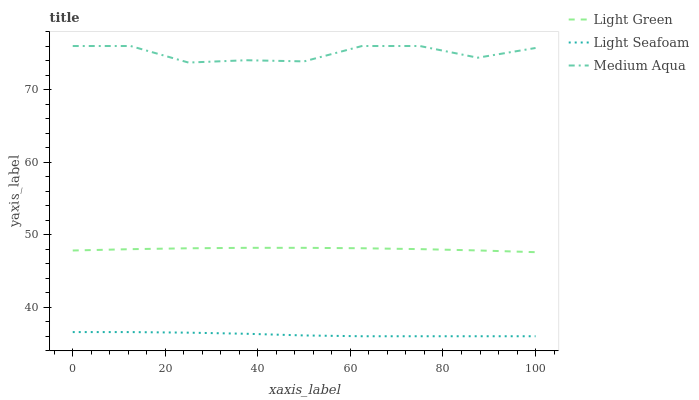Does Light Green have the minimum area under the curve?
Answer yes or no. No. Does Light Green have the maximum area under the curve?
Answer yes or no. No. Is Medium Aqua the smoothest?
Answer yes or no. No. Is Light Green the roughest?
Answer yes or no. No. Does Light Green have the lowest value?
Answer yes or no. No. Does Light Green have the highest value?
Answer yes or no. No. Is Light Seafoam less than Medium Aqua?
Answer yes or no. Yes. Is Medium Aqua greater than Light Green?
Answer yes or no. Yes. Does Light Seafoam intersect Medium Aqua?
Answer yes or no. No. 